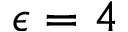<formula> <loc_0><loc_0><loc_500><loc_500>\epsilon = 4</formula> 